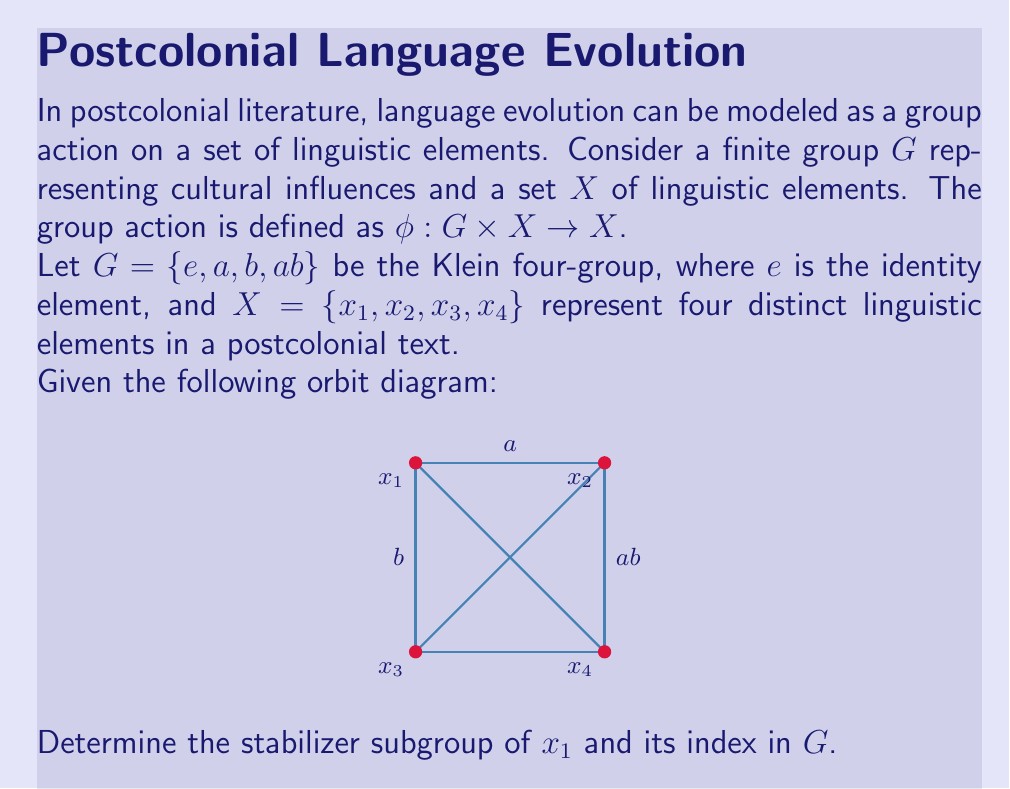Could you help me with this problem? To solve this problem, we'll follow these steps:

1) First, let's recall the definitions:
   - The stabilizer of an element $x \in X$ is $\text{Stab}_G(x) = \{g \in G : g \cdot x = x\}$
   - The index of a subgroup $H$ in $G$ is $[G:H] = \frac{|G|}{|H|}$

2) From the orbit diagram, we can see how each group element acts on $x_1$:
   - $e \cdot x_1 = x_1$ (identity always fixes every element)
   - $a \cdot x_1 = x_2$
   - $b \cdot x_1 = x_3$
   - $ab \cdot x_1 = x_4$

3) The stabilizer of $x_1$ consists of elements that fix $x_1$. From step 2, we can see that only the identity element $e$ fixes $x_1$.

4) Therefore, $\text{Stab}_G(x_1) = \{e\}$

5) To find the index, we need to calculate:
   $[G:\text{Stab}_G(x_1)] = \frac{|G|}{|\text{Stab}_G(x_1)|}$

6) We know that $|G| = 4$ (Klein four-group has 4 elements) and $|\text{Stab}_G(x_1)| = 1$

7) Thus, $[G:\text{Stab}_G(x_1)] = \frac{4}{1} = 4$

This result reflects the fact that the orbit of $x_1$ under the group action includes all four elements of $X$, indicating a full transformation of the linguistic element under all cultural influences represented by the group.
Answer: $\text{Stab}_G(x_1) = \{e\}$, index $[G:\text{Stab}_G(x_1)] = 4$ 